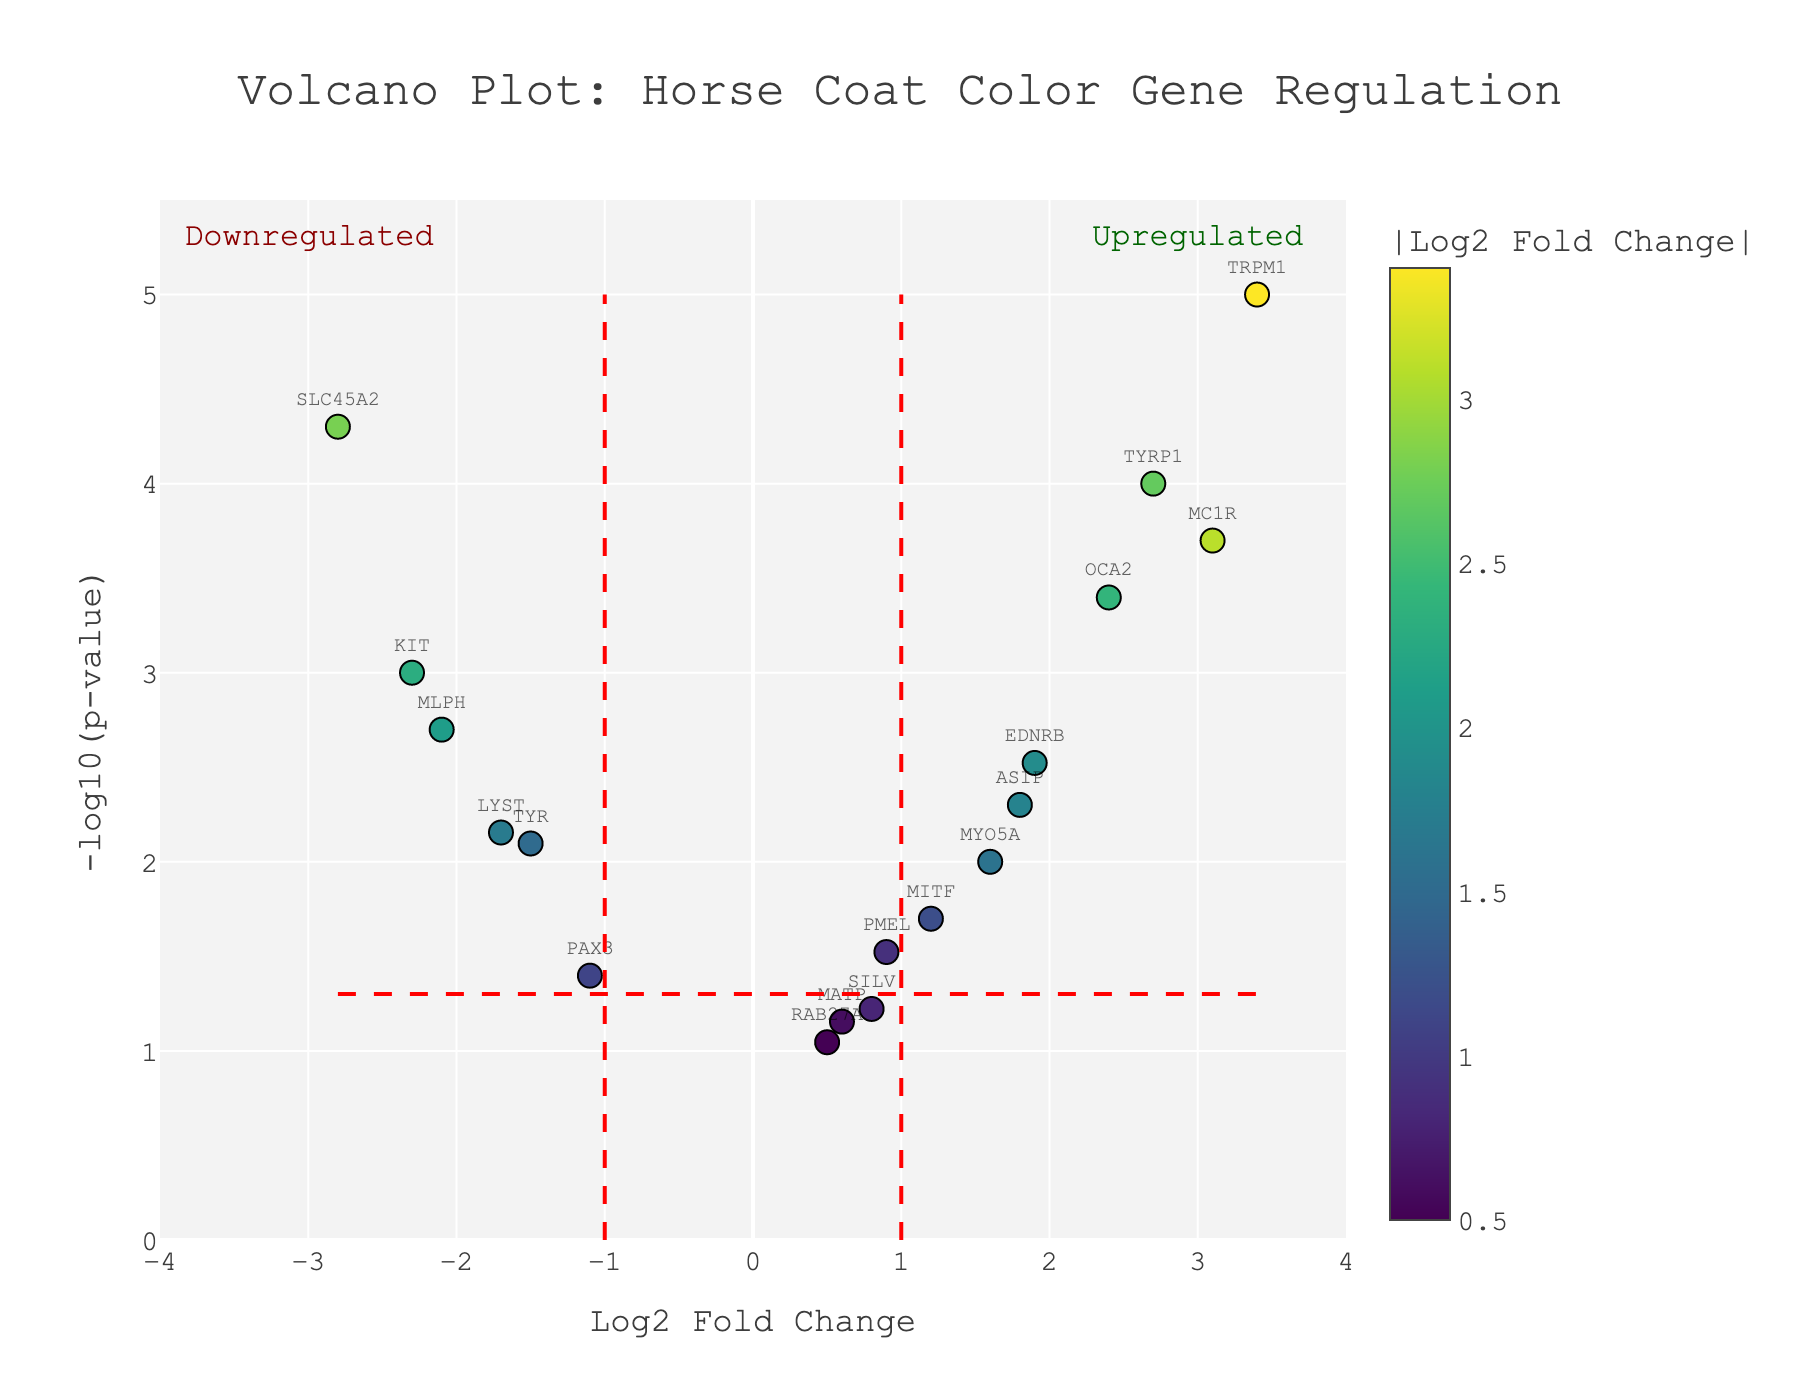what is the title of the figure? The figure's title is typically displayed at the top and is clearly labeled. In this case, it reads: "Volcano Plot: Horse Coat Color Gene Regulation"
Answer: Volcano Plot: Horse Coat Color Gene Regulation What does the x-axis represent in the plot? The x-axis label provides information about what is plotted along the horizontal direction. Here, it is labeled "Log2 Fold Change," indicating that it represents the log2 fold change values of the genes.
Answer: Log2 Fold Change How many genes have a significant downregulation (Log2 Fold Change < -1 and P-value < 0.05)? We count the number of genes that are located to the left of the -1 Log2 Fold Change threshold line and above the -log10(0.05) P-value threshold line. The genes that meet these criteria are KIT, TYR, SLC45A2, and MLPH.
Answer: 4 Which gene has the highest upregulation (highest positive Log2 Fold Change)? To find the gene with the highest upregulation, look for the gene with the highest positive value on the x-axis. TRPM1 has the highest Log2 Fold Change of 3.4.
Answer: TRPM1 What gene has the lowest p-value? The lowest p-value corresponds to the highest -log10(p-value) on the y-axis. TRPM1, with 3.4 Log2 Fold Change and a p-value of 0.00001, has the highest -log10(p-value).
Answer: TRPM1 Which three genes are annotated as significantly upregulated (Log2 Fold Change > 1 and P-value < 0.05) and have the highest -log10(p-value)? To find the top three significantly upregulated genes with the highest -log10(p-value), identify those right of the 1 Log2 Fold Change threshold and above the -log10(0.05) P-value threshold. The three genes are TRPM1, TYRP1, and MC1R.
Answer: TRPM1, TYRP1, and MC1R Are there more significantly upregulated or downregulated genes in the figure? Compare the number of genes to the right of the 1 Log2 Fold Change threshold and above the -log10(0.05) P-value threshold to the number left of the -1 Log2 Fold Change threshold and above the same p-value threshold. There are 4 significantly downregulated genes (KIT, TYR, SLC45A2, MLPH) and 5 significantly upregulated genes (ASIP, MC1R, TYRP1, EDNRB, TRPM1).
Answer: More significantly upregulated genes Which gene has a Log2 Fold Change closest to zero but is still statistically significant? Find the gene with a Log2 Fold Change value closest to zero but above the p-value threshold line (i.e., -log10(0.05)). PMEL has a Log2 Fold Change of 0.9 and a p-value of 0.03.
Answer: PMEL What does the color of a data point represent in this plot? The color intensity of a data point represents the absolute value of the Log2 Fold Change for that gene. The color scale is Viridis, which ranges from yellow to blue as the absolute value increases.
Answer: Absolute value of Log2 Fold Change How many genes have non-significant differential expression (P-value >= 0.05)? Count the genes with -log10(p-value) <= 1.30 (equivalent to p-value >= 0.05). These genes are MATP, SILV, and RAB27A.
Answer: 3 